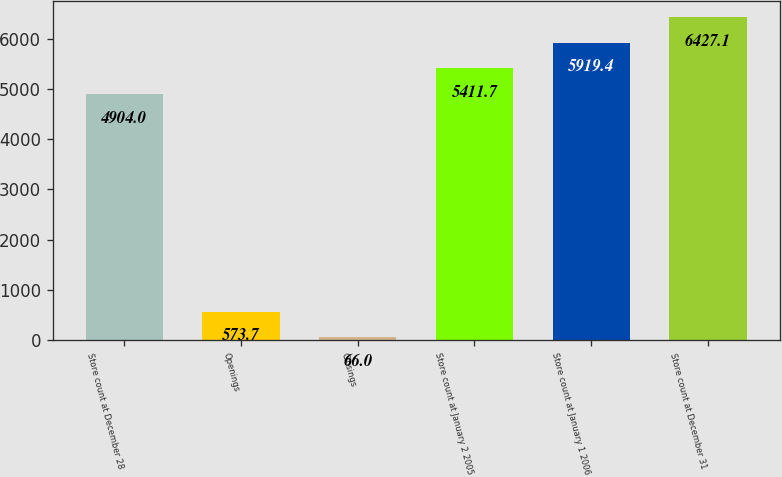<chart> <loc_0><loc_0><loc_500><loc_500><bar_chart><fcel>Store count at December 28<fcel>Openings<fcel>Closings<fcel>Store count at January 2 2005<fcel>Store count at January 1 2006<fcel>Store count at December 31<nl><fcel>4904<fcel>573.7<fcel>66<fcel>5411.7<fcel>5919.4<fcel>6427.1<nl></chart> 